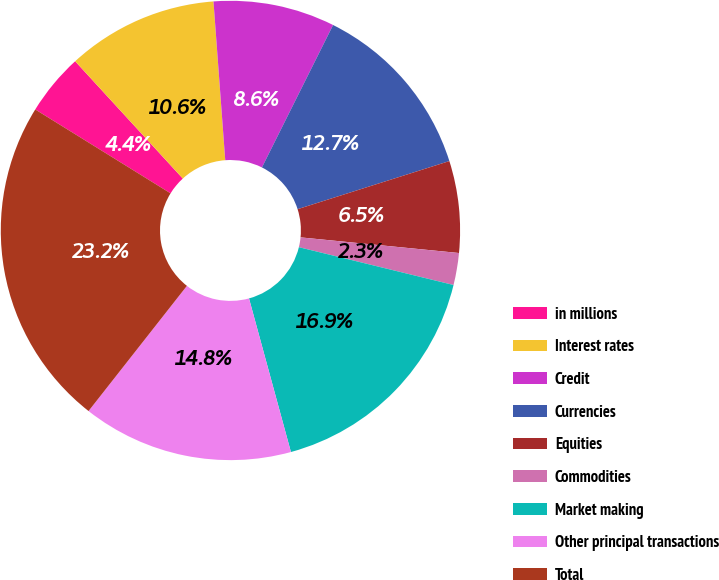Convert chart to OTSL. <chart><loc_0><loc_0><loc_500><loc_500><pie_chart><fcel>in millions<fcel>Interest rates<fcel>Credit<fcel>Currencies<fcel>Equities<fcel>Commodities<fcel>Market making<fcel>Other principal transactions<fcel>Total<nl><fcel>4.35%<fcel>10.64%<fcel>8.55%<fcel>12.74%<fcel>6.45%<fcel>2.25%<fcel>16.94%<fcel>14.84%<fcel>23.23%<nl></chart> 